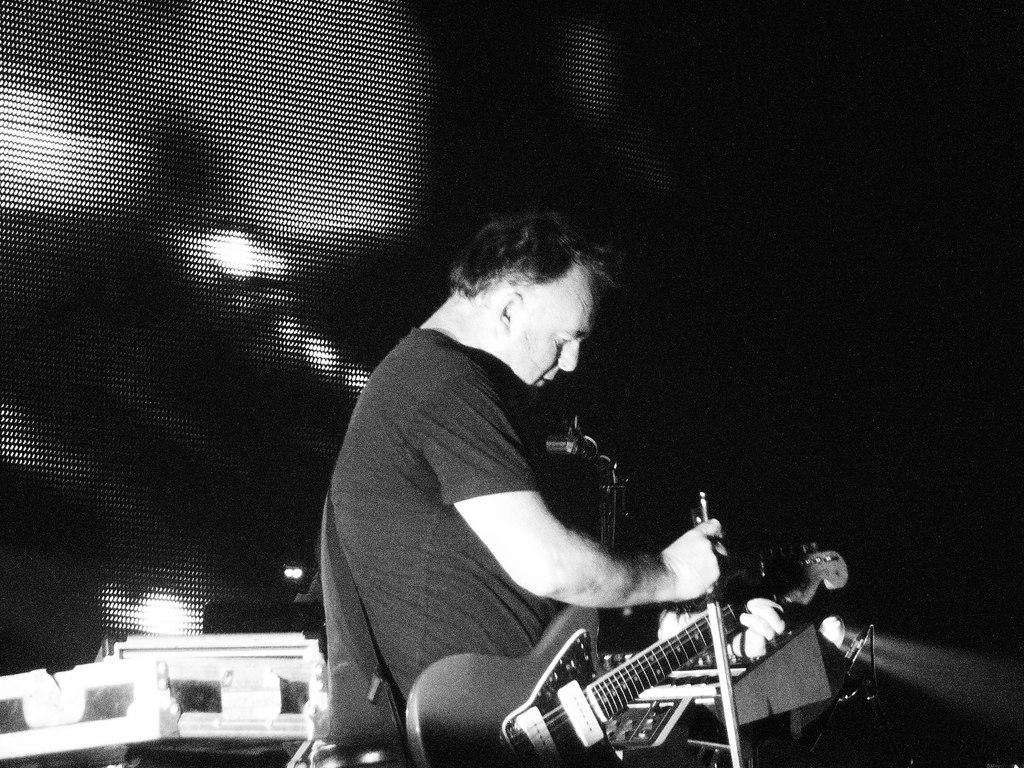What is the man in the image holding? The man is holding a guitar. What else can be seen in the image besides the man and the guitar? There are some objects in the image. What is visible in the background of the image? There is a screen visible in the background of the image. What type of key is the man using to unlock the hall in the image? There is no key or hall present in the image; it only features a man holding a guitar and some objects in the background. 